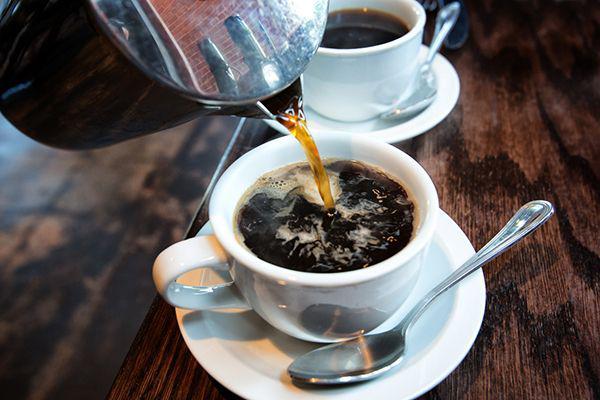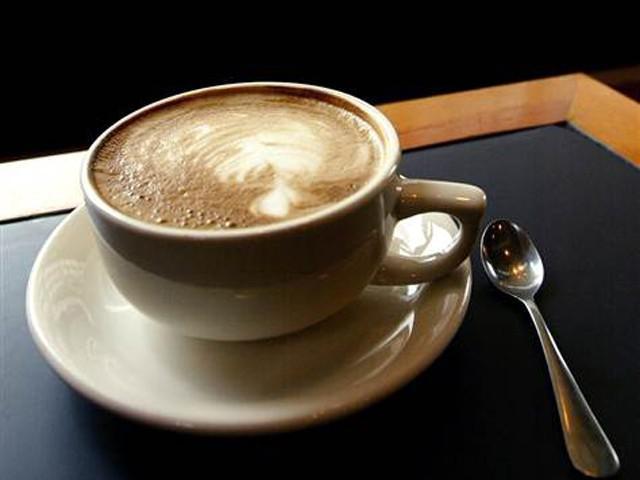The first image is the image on the left, the second image is the image on the right. For the images shown, is this caption "All cups have patterns created by swirls of cream in a brown beverage showing at their tops." true? Answer yes or no. No. The first image is the image on the left, the second image is the image on the right. Examine the images to the left and right. Is the description "All the coffees contain milk." accurate? Answer yes or no. No. 